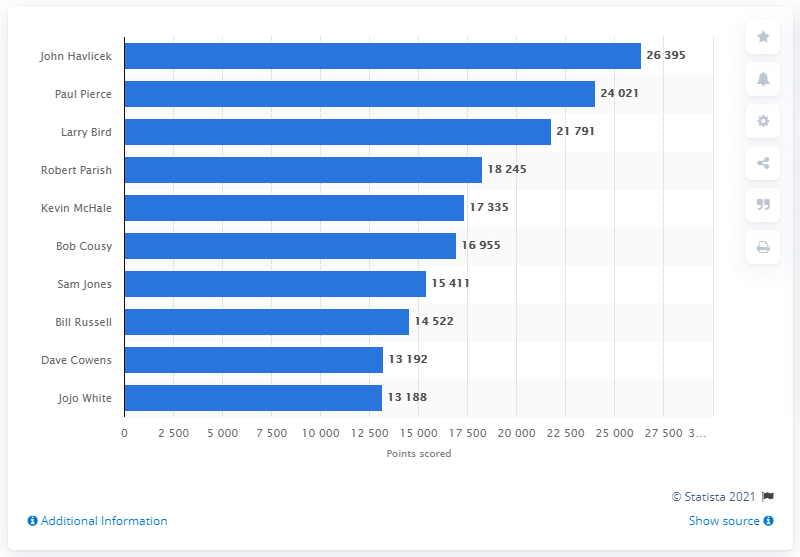Draw attention to some important aspects in this diagram. John Havlicek is the career points leader of the Boston Celtics. 